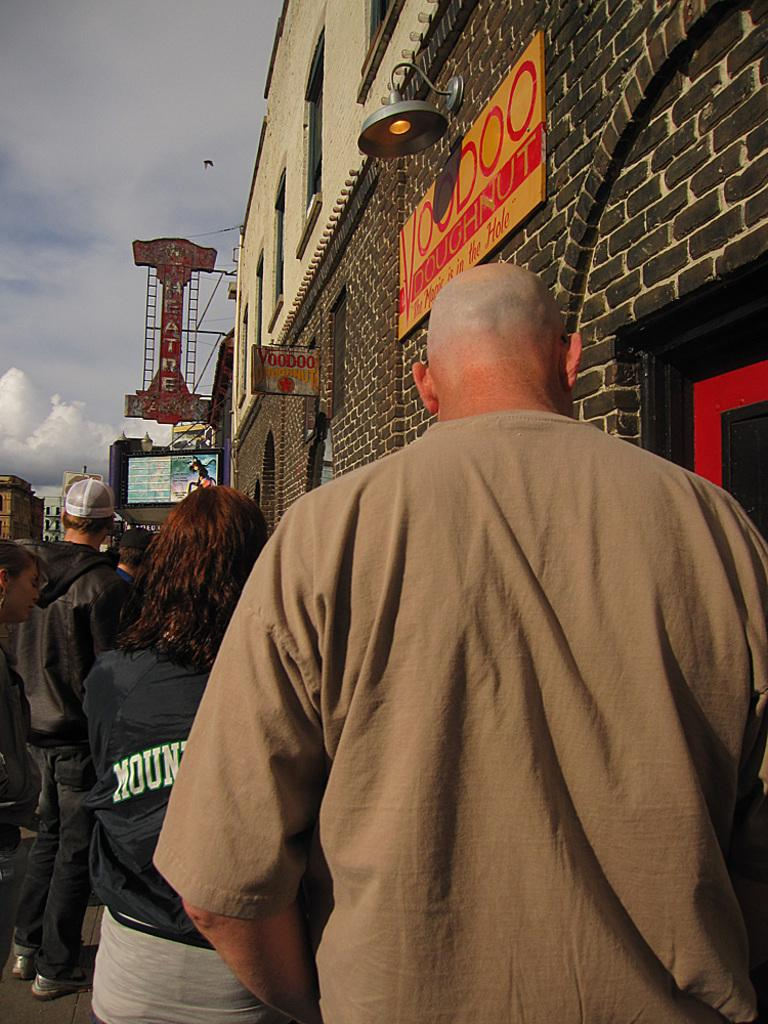What is the main subject of the image? The main subject of the image is a group of people standing. What can be seen on the right side of the image? There is a wall on the right side of the image. What objects are present in the image besides the people and the wall? There are boards, lights, and hoardings in the image. What is visible at the top of the image? The sky is visible at the top of the image. What type of substance is being emitted by the person in the image? There is no person emitting any substance in the image; it only shows a group of people standing. What scent can be detected from the image? There is no scent associated with the image, as it is a visual representation. 